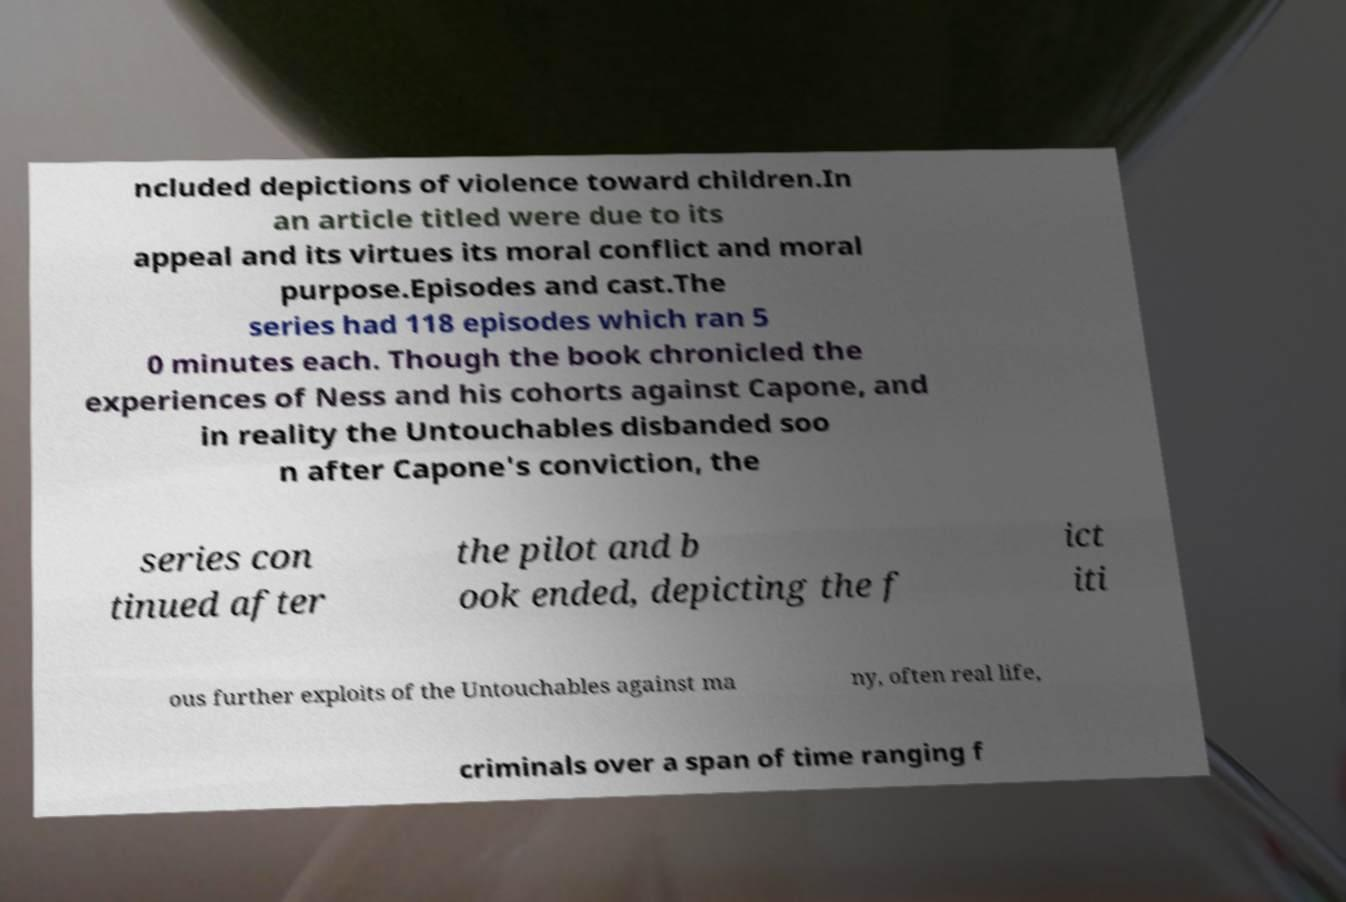What messages or text are displayed in this image? I need them in a readable, typed format. ncluded depictions of violence toward children.In an article titled were due to its appeal and its virtues its moral conflict and moral purpose.Episodes and cast.The series had 118 episodes which ran 5 0 minutes each. Though the book chronicled the experiences of Ness and his cohorts against Capone, and in reality the Untouchables disbanded soo n after Capone's conviction, the series con tinued after the pilot and b ook ended, depicting the f ict iti ous further exploits of the Untouchables against ma ny, often real life, criminals over a span of time ranging f 